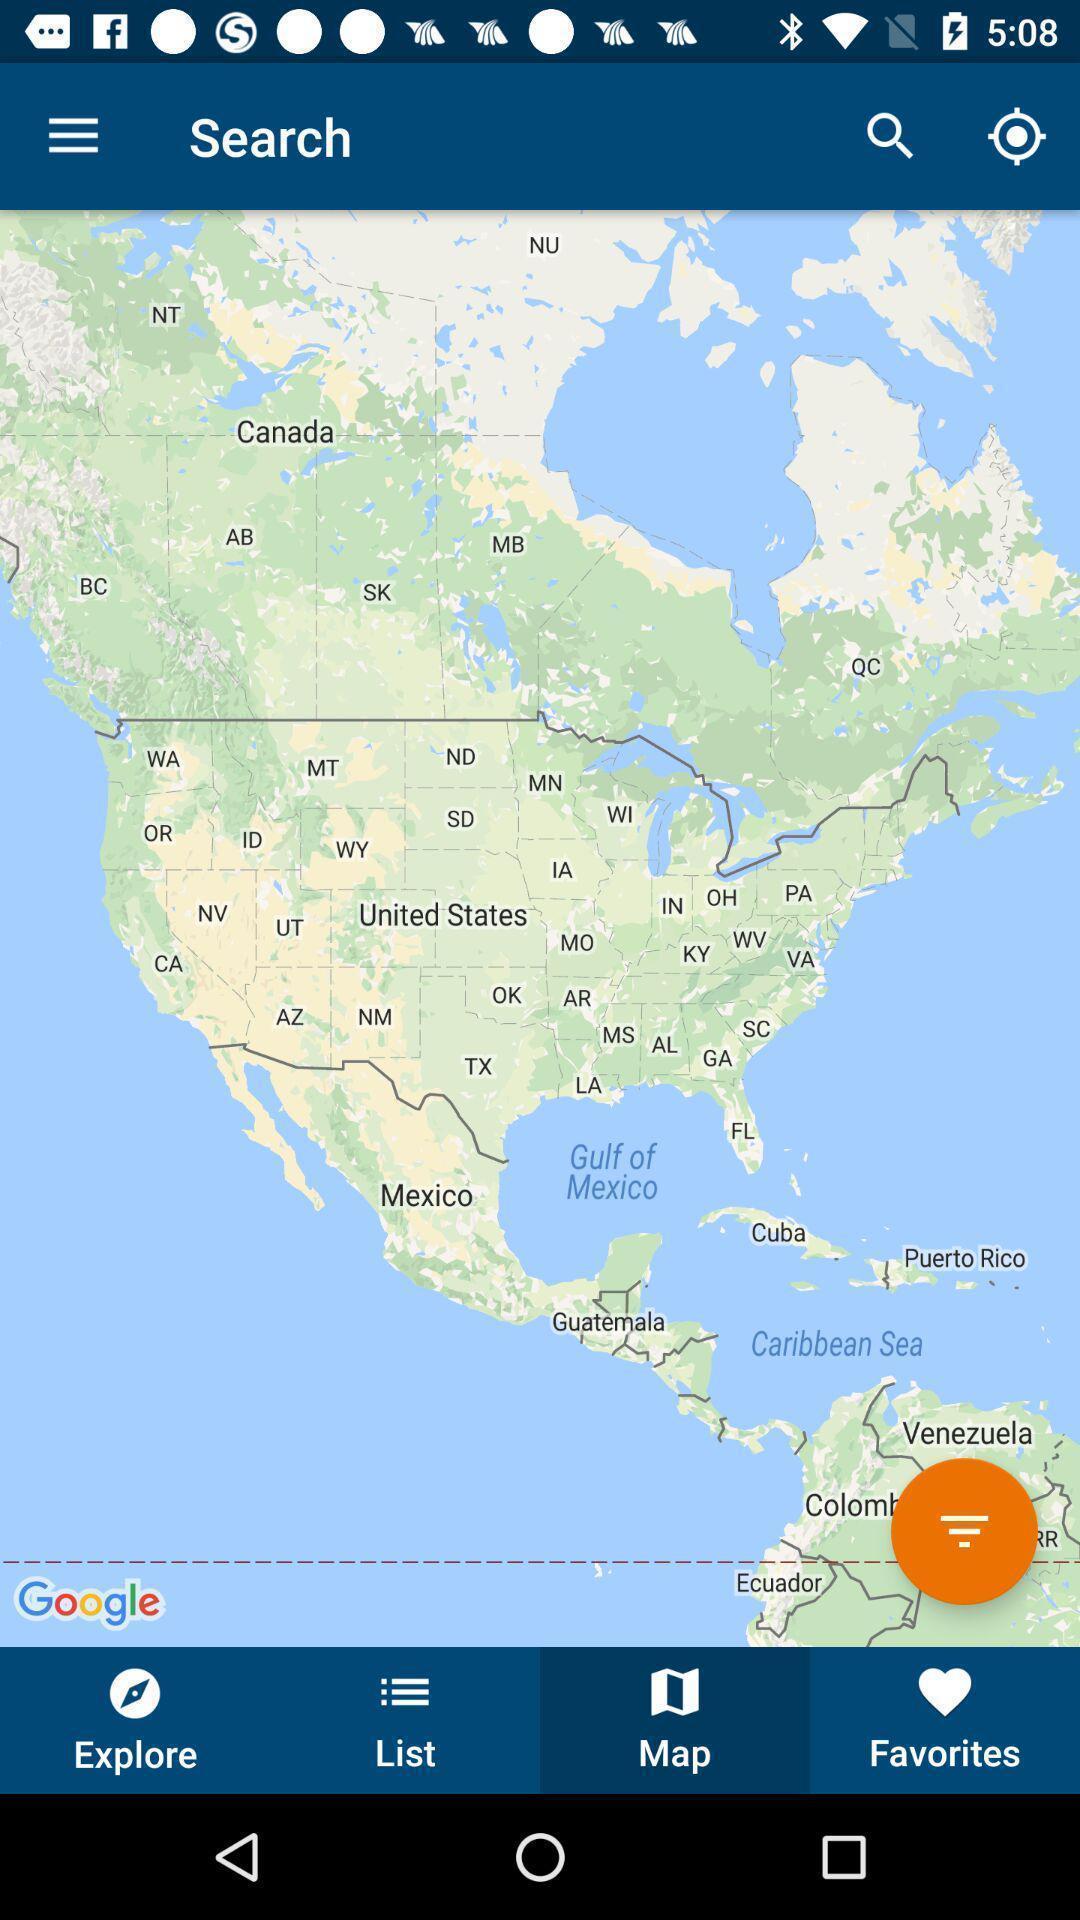Describe this image in words. Search bar showing in gps application. 